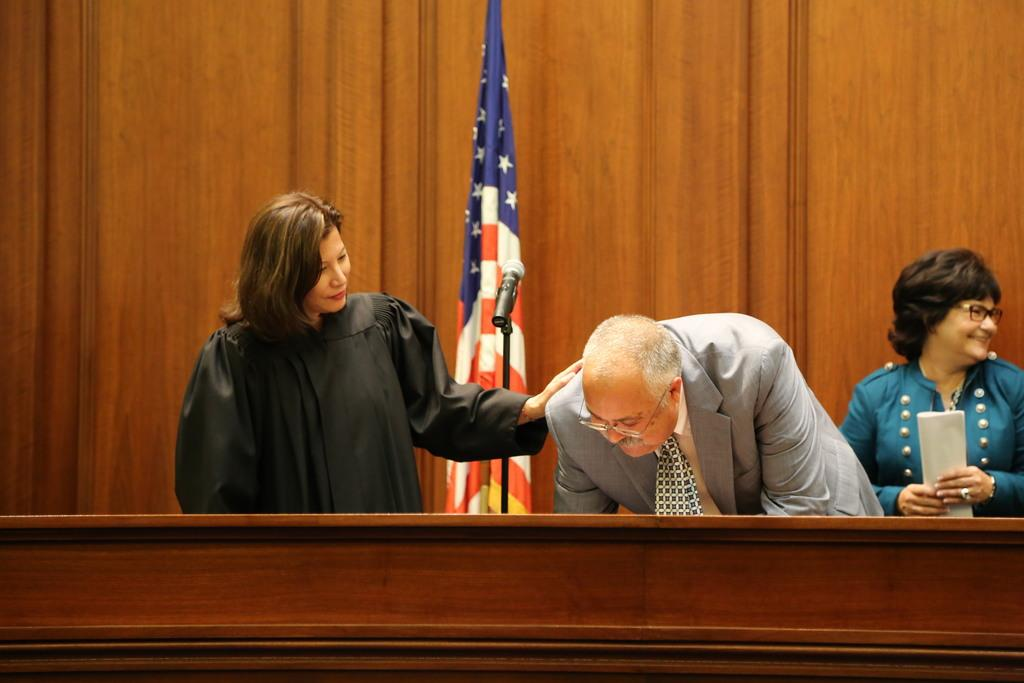How many people are present in the image? There are three people in the image. What can be seen in the image besides the people? There is a mic, a flag, and wooden objects in the image. Can you describe the woman in the image? The woman in the image is wearing spectacles, holding a paper, and smiling. What type of cheese is being used to improve the acoustics in the image? There is no cheese present in the image, and the acoustics are not mentioned, so it cannot be determined if any cheese is being used for that purpose. 